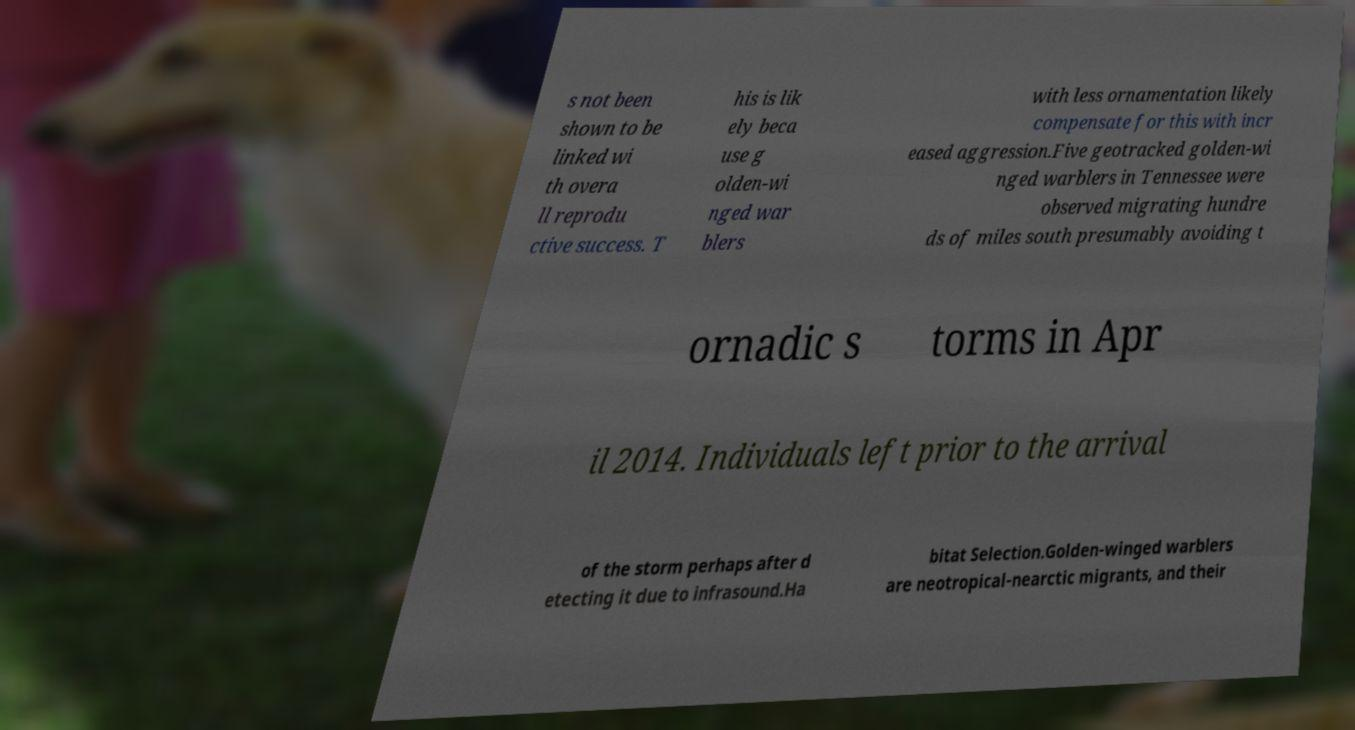Can you accurately transcribe the text from the provided image for me? s not been shown to be linked wi th overa ll reprodu ctive success. T his is lik ely beca use g olden-wi nged war blers with less ornamentation likely compensate for this with incr eased aggression.Five geotracked golden-wi nged warblers in Tennessee were observed migrating hundre ds of miles south presumably avoiding t ornadic s torms in Apr il 2014. Individuals left prior to the arrival of the storm perhaps after d etecting it due to infrasound.Ha bitat Selection.Golden-winged warblers are neotropical-nearctic migrants, and their 